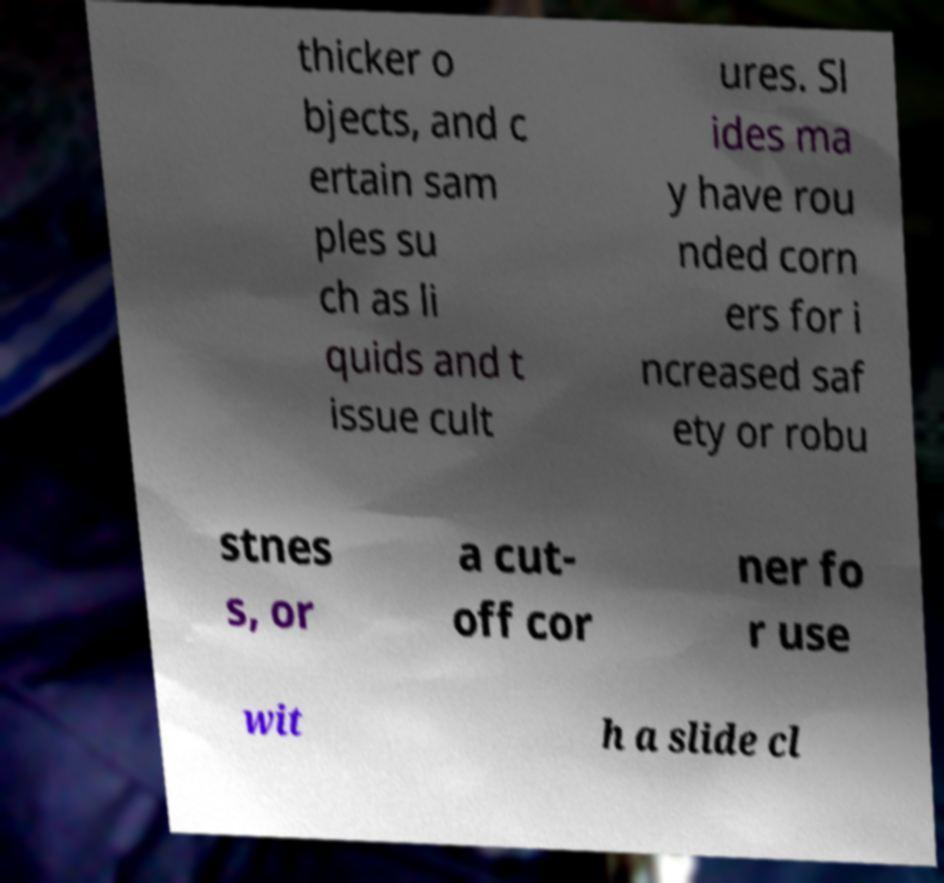Can you read and provide the text displayed in the image?This photo seems to have some interesting text. Can you extract and type it out for me? thicker o bjects, and c ertain sam ples su ch as li quids and t issue cult ures. Sl ides ma y have rou nded corn ers for i ncreased saf ety or robu stnes s, or a cut- off cor ner fo r use wit h a slide cl 